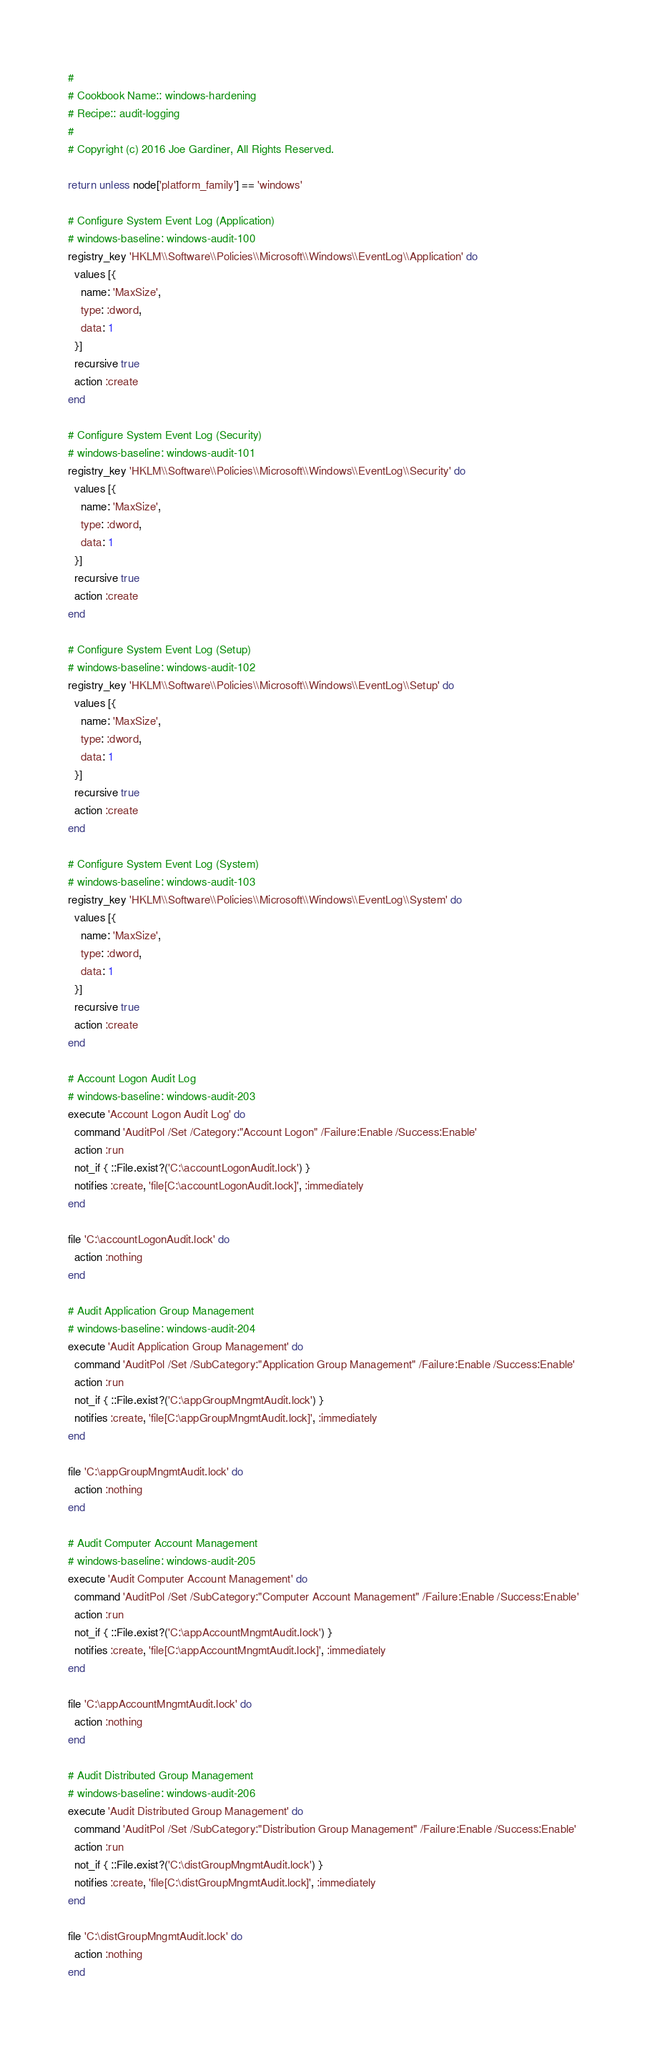<code> <loc_0><loc_0><loc_500><loc_500><_Ruby_>#
# Cookbook Name:: windows-hardening
# Recipe:: audit-logging
#
# Copyright (c) 2016 Joe Gardiner, All Rights Reserved.

return unless node['platform_family'] == 'windows'

# Configure System Event Log (Application)
# windows-baseline: windows-audit-100
registry_key 'HKLM\\Software\\Policies\\Microsoft\\Windows\\EventLog\\Application' do
  values [{
    name: 'MaxSize',
    type: :dword,
    data: 1
  }]
  recursive true
  action :create
end

# Configure System Event Log (Security)
# windows-baseline: windows-audit-101
registry_key 'HKLM\\Software\\Policies\\Microsoft\\Windows\\EventLog\\Security' do
  values [{
    name: 'MaxSize',
    type: :dword,
    data: 1
  }]
  recursive true
  action :create
end

# Configure System Event Log (Setup)
# windows-baseline: windows-audit-102
registry_key 'HKLM\\Software\\Policies\\Microsoft\\Windows\\EventLog\\Setup' do
  values [{
    name: 'MaxSize',
    type: :dword,
    data: 1
  }]
  recursive true
  action :create
end

# Configure System Event Log (System)
# windows-baseline: windows-audit-103
registry_key 'HKLM\\Software\\Policies\\Microsoft\\Windows\\EventLog\\System' do
  values [{
    name: 'MaxSize',
    type: :dword,
    data: 1
  }]
  recursive true
  action :create
end

# Account Logon Audit Log
# windows-baseline: windows-audit-203
execute 'Account Logon Audit Log' do
  command 'AuditPol /Set /Category:"Account Logon" /Failure:Enable /Success:Enable'
  action :run
  not_if { ::File.exist?('C:\accountLogonAudit.lock') }
  notifies :create, 'file[C:\accountLogonAudit.lock]', :immediately
end

file 'C:\accountLogonAudit.lock' do
  action :nothing
end

# Audit Application Group Management
# windows-baseline: windows-audit-204
execute 'Audit Application Group Management' do
  command 'AuditPol /Set /SubCategory:"Application Group Management" /Failure:Enable /Success:Enable'
  action :run
  not_if { ::File.exist?('C:\appGroupMngmtAudit.lock') }
  notifies :create, 'file[C:\appGroupMngmtAudit.lock]', :immediately
end

file 'C:\appGroupMngmtAudit.lock' do
  action :nothing
end

# Audit Computer Account Management
# windows-baseline: windows-audit-205
execute 'Audit Computer Account Management' do
  command 'AuditPol /Set /SubCategory:"Computer Account Management" /Failure:Enable /Success:Enable'
  action :run
  not_if { ::File.exist?('C:\appAccountMngmtAudit.lock') }
  notifies :create, 'file[C:\appAccountMngmtAudit.lock]', :immediately
end

file 'C:\appAccountMngmtAudit.lock' do
  action :nothing
end

# Audit Distributed Group Management
# windows-baseline: windows-audit-206
execute 'Audit Distributed Group Management' do
  command 'AuditPol /Set /SubCategory:"Distribution Group Management" /Failure:Enable /Success:Enable'
  action :run
  not_if { ::File.exist?('C:\distGroupMngmtAudit.lock') }
  notifies :create, 'file[C:\distGroupMngmtAudit.lock]', :immediately
end

file 'C:\distGroupMngmtAudit.lock' do
  action :nothing
end
</code> 